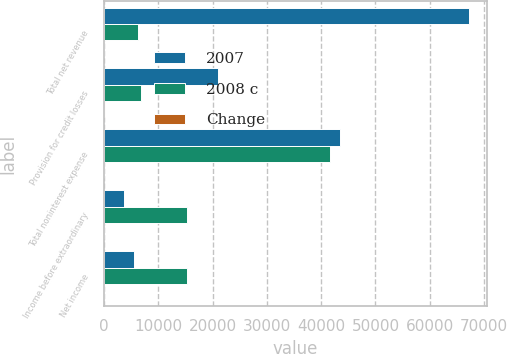Convert chart to OTSL. <chart><loc_0><loc_0><loc_500><loc_500><stacked_bar_chart><ecel><fcel>Total net revenue<fcel>Provision for credit losses<fcel>Total noninterest expense<fcel>Income before extraordinary<fcel>Net income<nl><fcel>2007<fcel>67252<fcel>20979<fcel>43500<fcel>3699<fcel>5605<nl><fcel>2008 c<fcel>6234.5<fcel>6864<fcel>41703<fcel>15365<fcel>15365<nl><fcel>Change<fcel>6<fcel>206<fcel>4<fcel>76<fcel>64<nl></chart> 